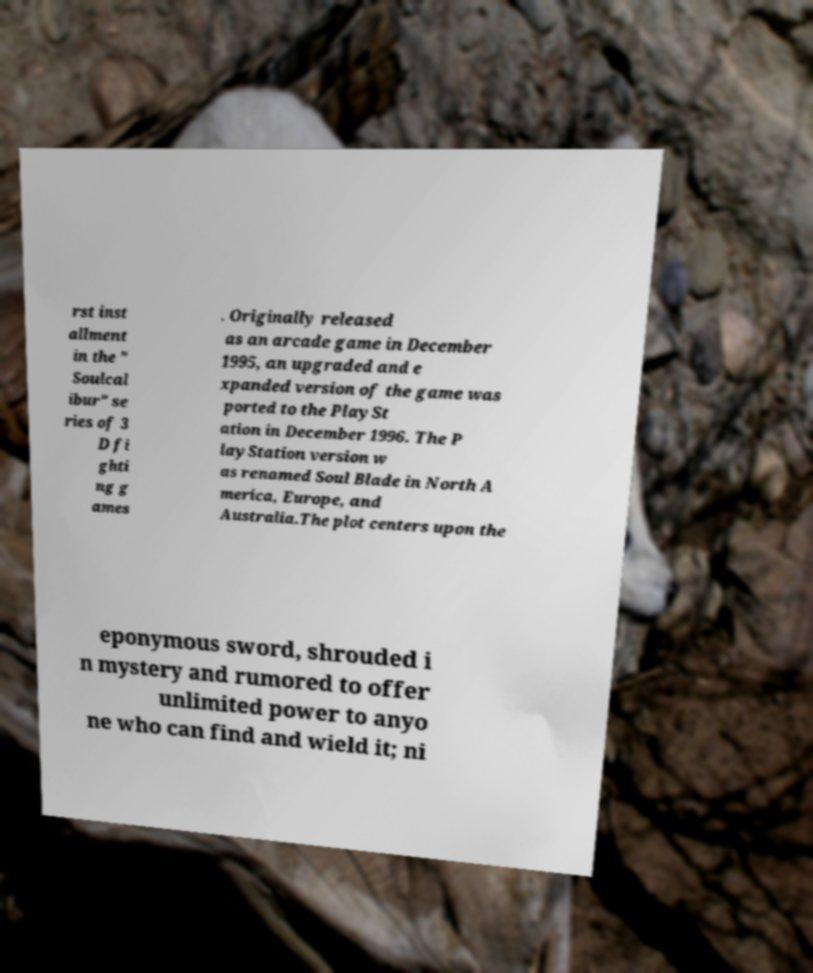Could you extract and type out the text from this image? rst inst allment in the " Soulcal ibur" se ries of 3 D fi ghti ng g ames . Originally released as an arcade game in December 1995, an upgraded and e xpanded version of the game was ported to the PlaySt ation in December 1996. The P layStation version w as renamed Soul Blade in North A merica, Europe, and Australia.The plot centers upon the eponymous sword, shrouded i n mystery and rumored to offer unlimited power to anyo ne who can find and wield it; ni 